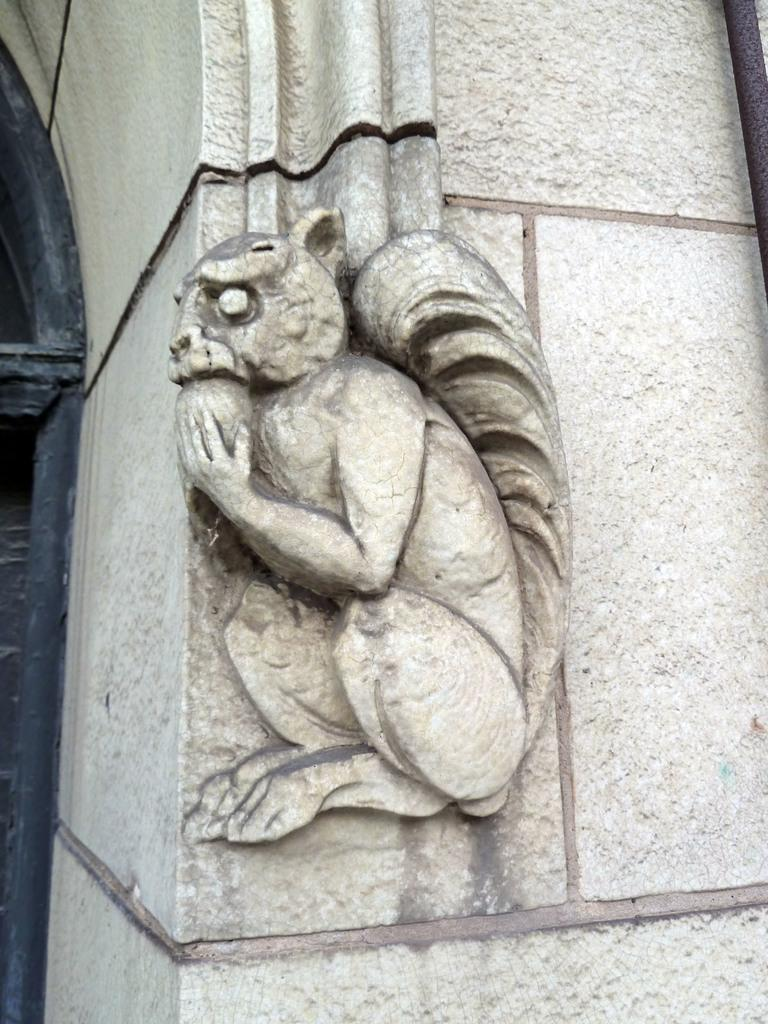What type of artwork is on the wall in the image? There is a sculpture of a squirrel on the wall in the image. What can be seen on the left side of the image? There is a door on the left side of the image. What is located on the right side of the image? There is a pole on the right side of the image. How many eggs are on the pole in the image? There are no eggs present in the image; it features a sculpture of a squirrel on the wall, a door on the left side, and a pole on the right side. What type of party is being held in the image? There is no party depicted in the image. 